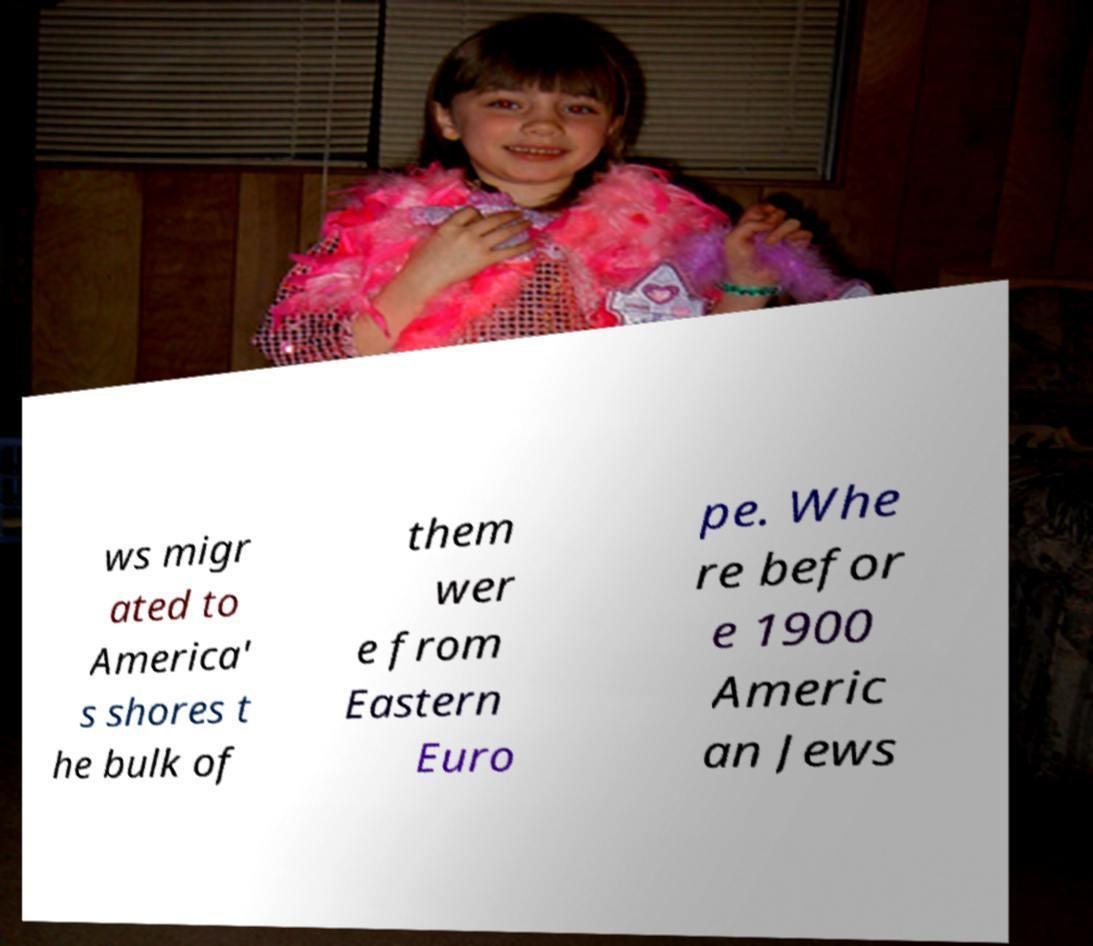I need the written content from this picture converted into text. Can you do that? ws migr ated to America' s shores t he bulk of them wer e from Eastern Euro pe. Whe re befor e 1900 Americ an Jews 